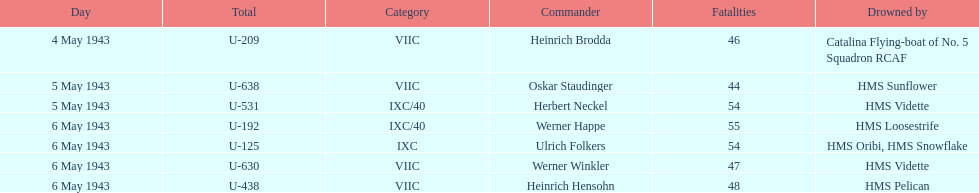Would you be able to parse every entry in this table? {'header': ['Day', 'Total', 'Category', 'Commander', 'Fatalities', 'Drowned by'], 'rows': [['4 May 1943', 'U-209', 'VIIC', 'Heinrich Brodda', '46', 'Catalina Flying-boat of No. 5 Squadron RCAF'], ['5 May 1943', 'U-638', 'VIIC', 'Oskar Staudinger', '44', 'HMS Sunflower'], ['5 May 1943', 'U-531', 'IXC/40', 'Herbert Neckel', '54', 'HMS Vidette'], ['6 May 1943', 'U-192', 'IXC/40', 'Werner Happe', '55', 'HMS Loosestrife'], ['6 May 1943', 'U-125', 'IXC', 'Ulrich Folkers', '54', 'HMS Oribi, HMS Snowflake'], ['6 May 1943', 'U-630', 'VIIC', 'Werner Winkler', '47', 'HMS Vidette'], ['6 May 1943', 'U-438', 'VIIC', 'Heinrich Hensohn', '48', 'HMS Pelican']]} Which u-boat had more than 54 casualties? U-192. 